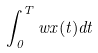Convert formula to latex. <formula><loc_0><loc_0><loc_500><loc_500>\int _ { 0 } ^ { T } w x ( t ) d t</formula> 